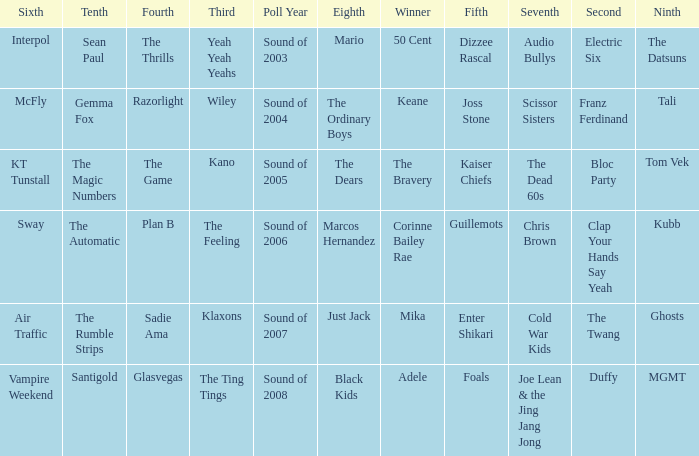When dizzee rascal is 5th, who was the winner? 50 Cent. 